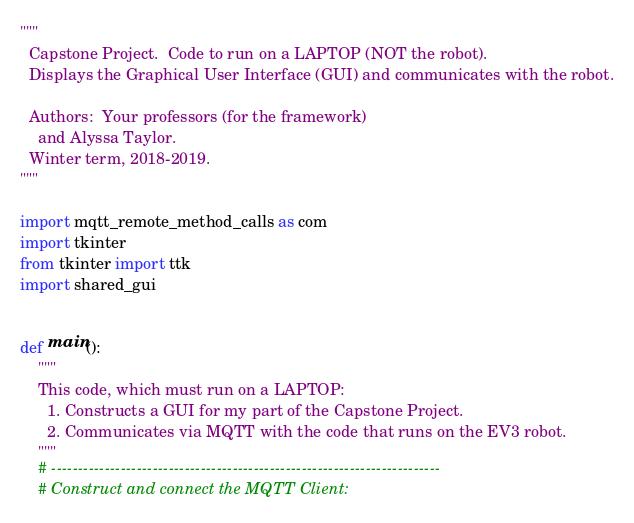<code> <loc_0><loc_0><loc_500><loc_500><_Python_>"""
  Capstone Project.  Code to run on a LAPTOP (NOT the robot).
  Displays the Graphical User Interface (GUI) and communicates with the robot.

  Authors:  Your professors (for the framework)
    and Alyssa Taylor.
  Winter term, 2018-2019.
"""

import mqtt_remote_method_calls as com
import tkinter
from tkinter import ttk
import shared_gui


def main():
    """
    This code, which must run on a LAPTOP:
      1. Constructs a GUI for my part of the Capstone Project.
      2. Communicates via MQTT with the code that runs on the EV3 robot.
    """
    # -------------------------------------------------------------------------
    # Construct and connect the MQTT Client:</code> 